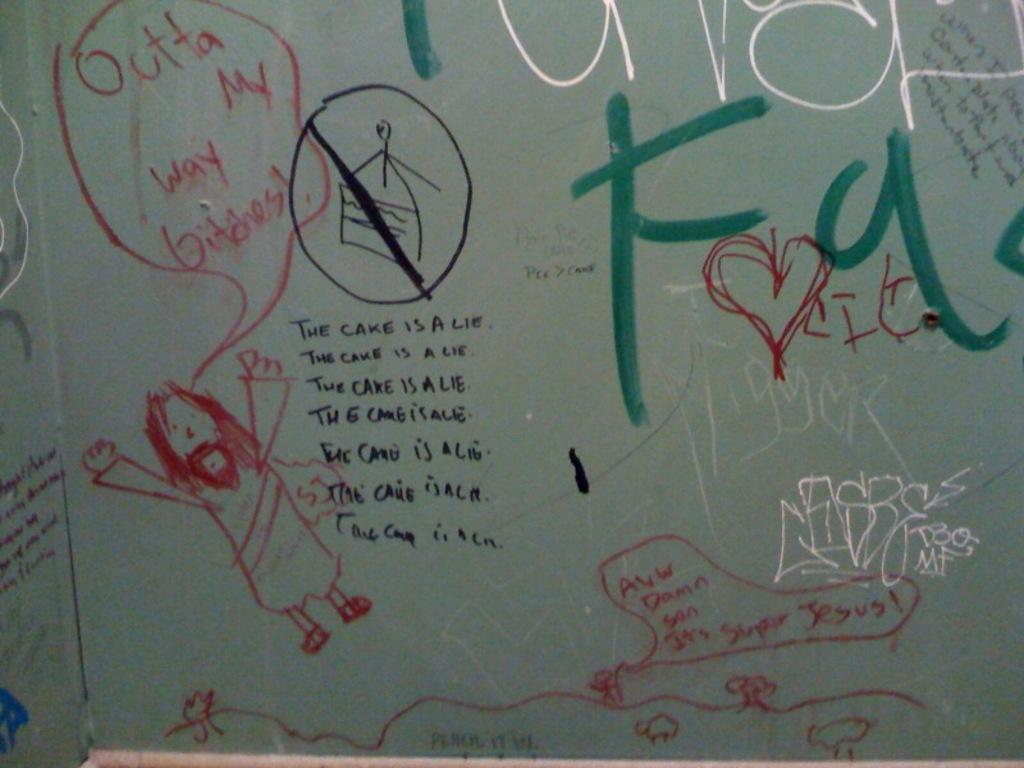Provide a one-sentence caption for the provided image. A bunch of graffiti with one of them saying the cake is a lie. 